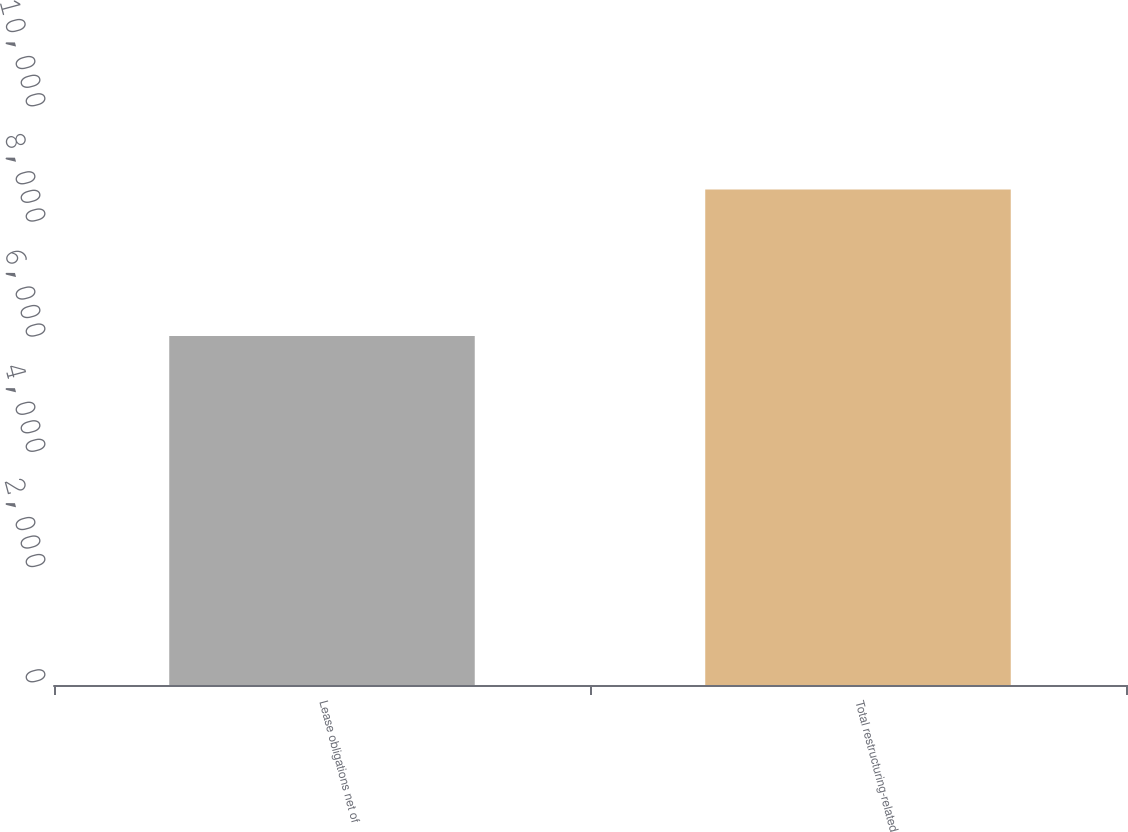Convert chart. <chart><loc_0><loc_0><loc_500><loc_500><bar_chart><fcel>Lease obligations net of<fcel>Total restructuring-related<nl><fcel>6060<fcel>8604<nl></chart> 